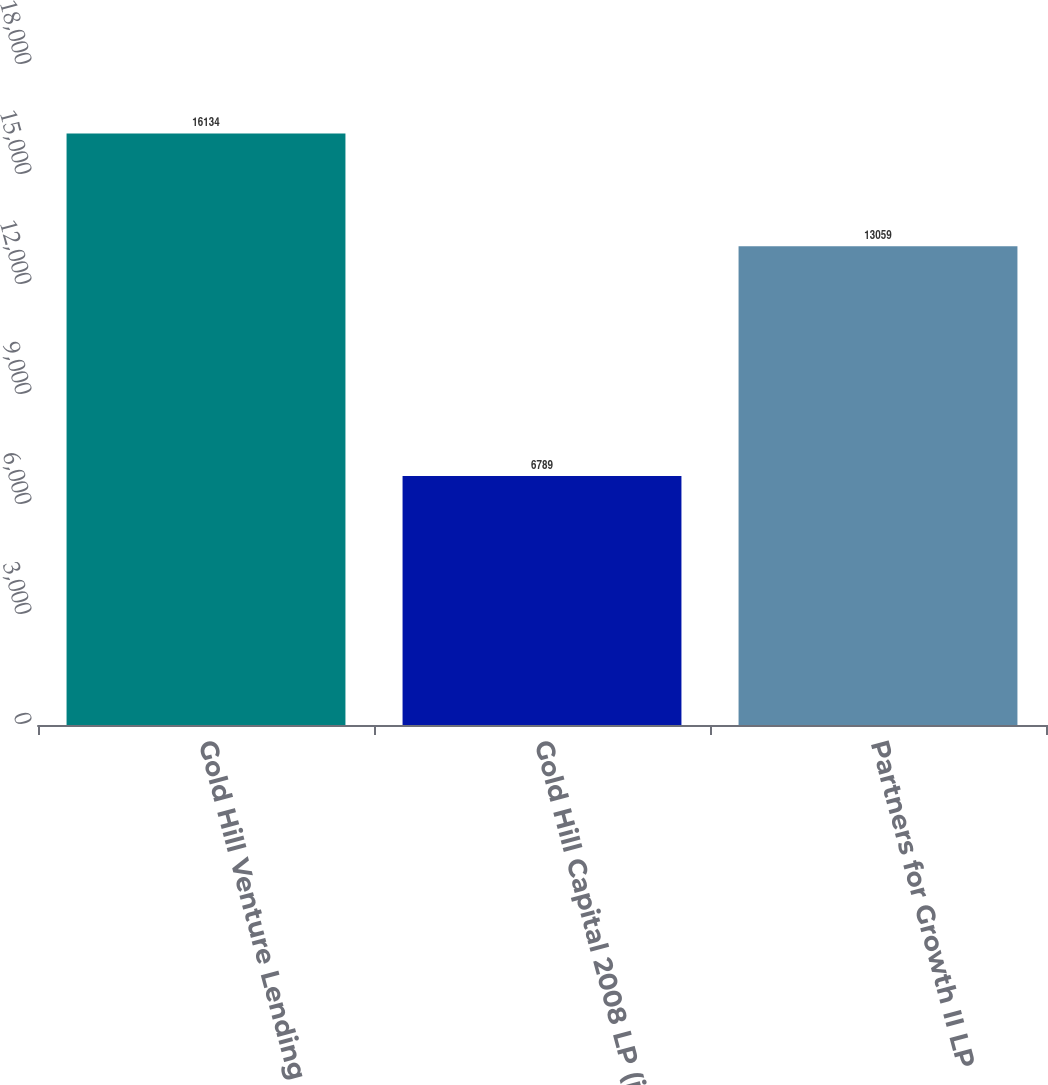Convert chart. <chart><loc_0><loc_0><loc_500><loc_500><bar_chart><fcel>Gold Hill Venture Lending 03<fcel>Gold Hill Capital 2008 LP (ii)<fcel>Partners for Growth II LP<nl><fcel>16134<fcel>6789<fcel>13059<nl></chart> 